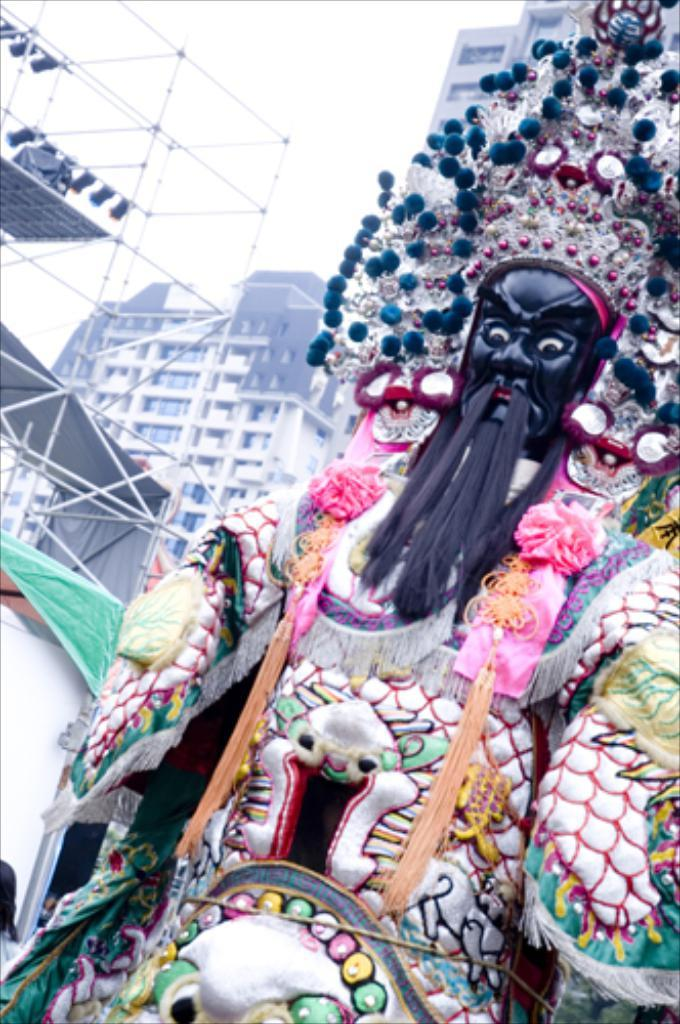What is the main subject of the image? There is an idol in the image. Can you identify the deity depicted by the idol? The idol appears to be of Lord Kali. What can be seen in the background of the image? There are buildings visible in the background of the image. What is visible at the top of the image? The sky is visible at the top of the image. What type of beef dish is being prepared in the image? There is no beef dish present in the image; it features an idol of Lord Kali. What type of apparel is the queen wearing in the image? There is no queen present in the image; it features an idol of Lord Kali. 